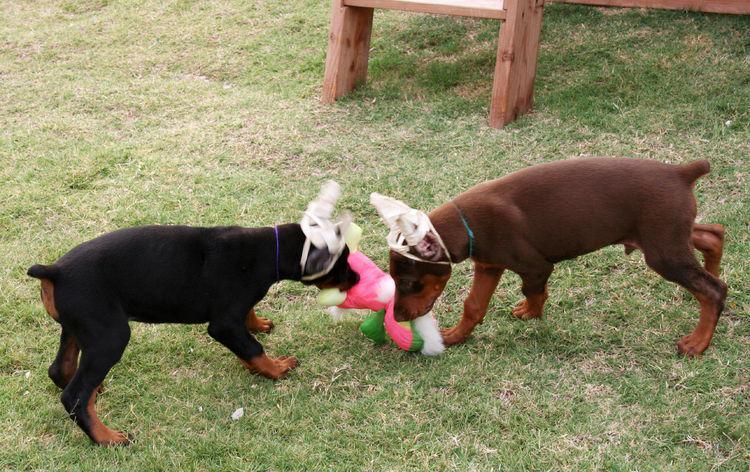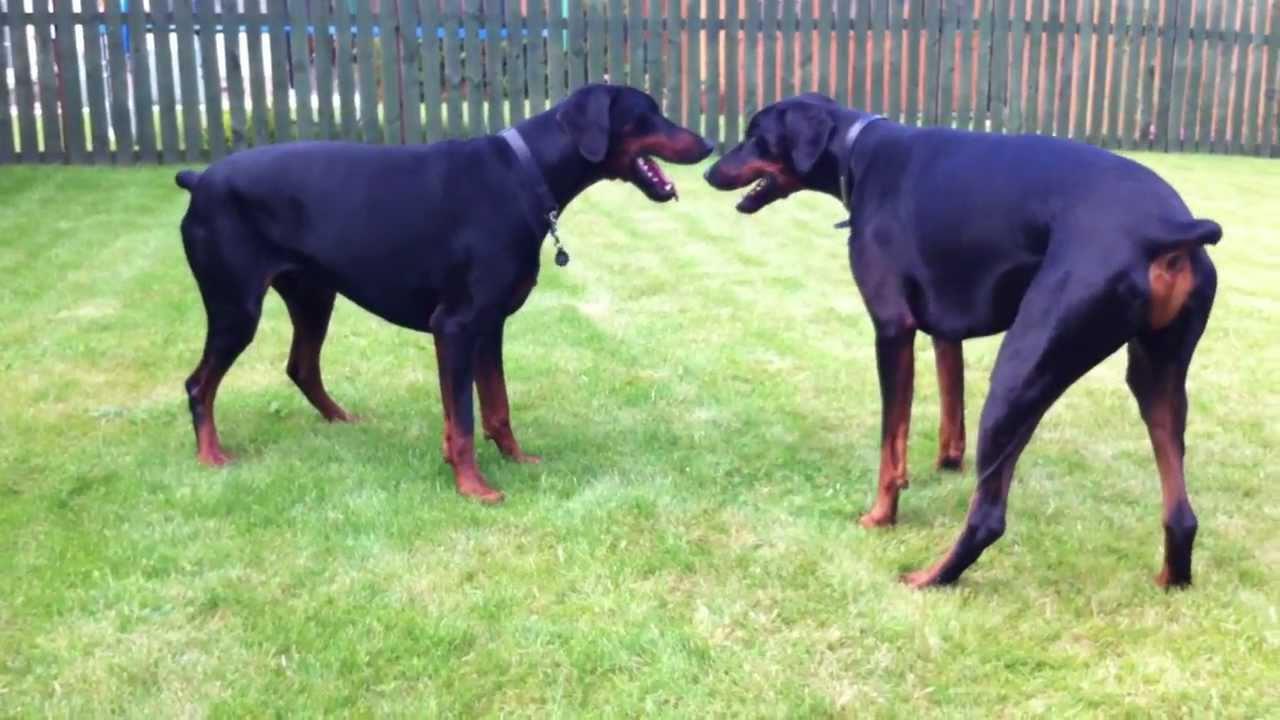The first image is the image on the left, the second image is the image on the right. For the images shown, is this caption "Each image shows two dogs of similar size interacting in close proximity." true? Answer yes or no. Yes. The first image is the image on the left, the second image is the image on the right. Analyze the images presented: Is the assertion "The right image contains exactly two dogs." valid? Answer yes or no. Yes. 